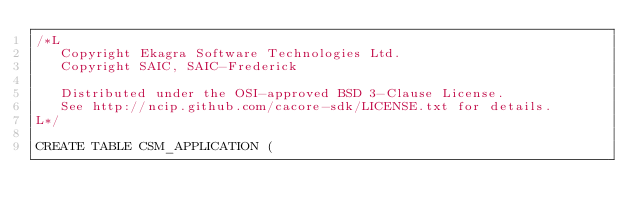Convert code to text. <code><loc_0><loc_0><loc_500><loc_500><_SQL_>/*L
   Copyright Ekagra Software Technologies Ltd.
   Copyright SAIC, SAIC-Frederick

   Distributed under the OSI-approved BSD 3-Clause License.
   See http://ncip.github.com/cacore-sdk/LICENSE.txt for details.
L*/

CREATE TABLE CSM_APPLICATION ( </code> 